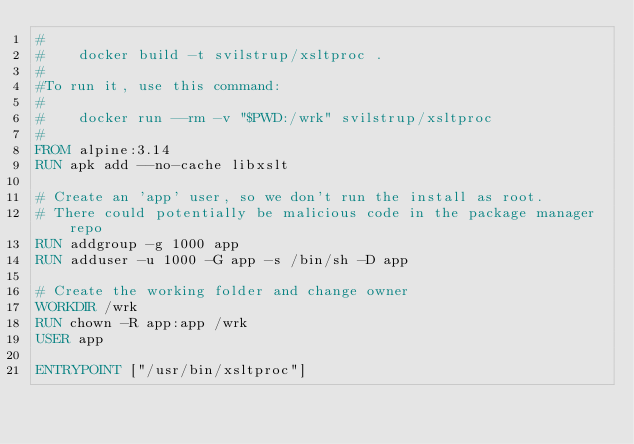<code> <loc_0><loc_0><loc_500><loc_500><_Dockerfile_>#
#    docker build -t svilstrup/xsltproc .
#
#To run it, use this command:
#
#    docker run --rm -v "$PWD:/wrk" svilstrup/xsltproc
#
FROM alpine:3.14
RUN apk add --no-cache libxslt

# Create an 'app' user, so we don't run the install as root. 
# There could potentially be malicious code in the package manager repo
RUN addgroup -g 1000 app
RUN adduser -u 1000 -G app -s /bin/sh -D app

# Create the working folder and change owner
WORKDIR /wrk
RUN chown -R app:app /wrk
USER app  

ENTRYPOINT ["/usr/bin/xsltproc"]
</code> 